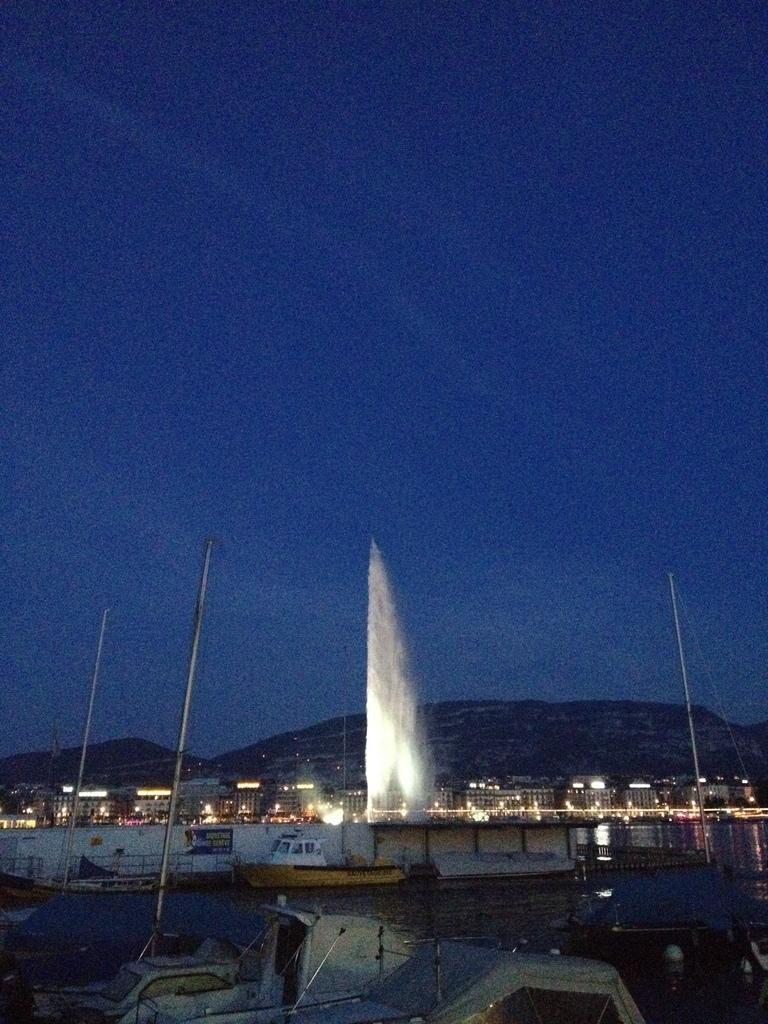What is on the water in the image? There are boats on the water in the image. What structure can be seen crossing over the water? There is a bridge in the image. What type of structures are visible with lights in the image? There are buildings with lights in the image. What type of natural feature can be seen in the background of the image? There are mountains visible in the image. What is visible above the structures and natural features in the image? The sky is visible in the image. Can you see a tub filled with pears in the image? There is no tub or pears present in the image. Is there any indication of thunder in the image? There is no mention of thunder or any weather-related phenomena in the image. 